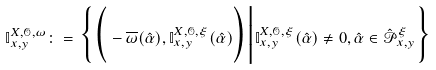<formula> <loc_0><loc_0><loc_500><loc_500>\mathbb { I } ^ { X , \mathcal { O } , \omega } _ { x , y } \colon = \Big \{ \Big ( - \overline { \omega } ( \hat { \alpha } ) , \mathbb { I } ^ { X , \mathcal { O } , \xi } _ { x , y } ( \hat { \alpha } ) \Big ) \Big | \mathbb { I } ^ { X , \mathcal { O } , \xi } _ { x , y } ( \hat { \alpha } ) \neq 0 , \hat { \alpha } \in \hat { \mathcal { P } } _ { x , y } ^ { \xi } \Big \}</formula> 